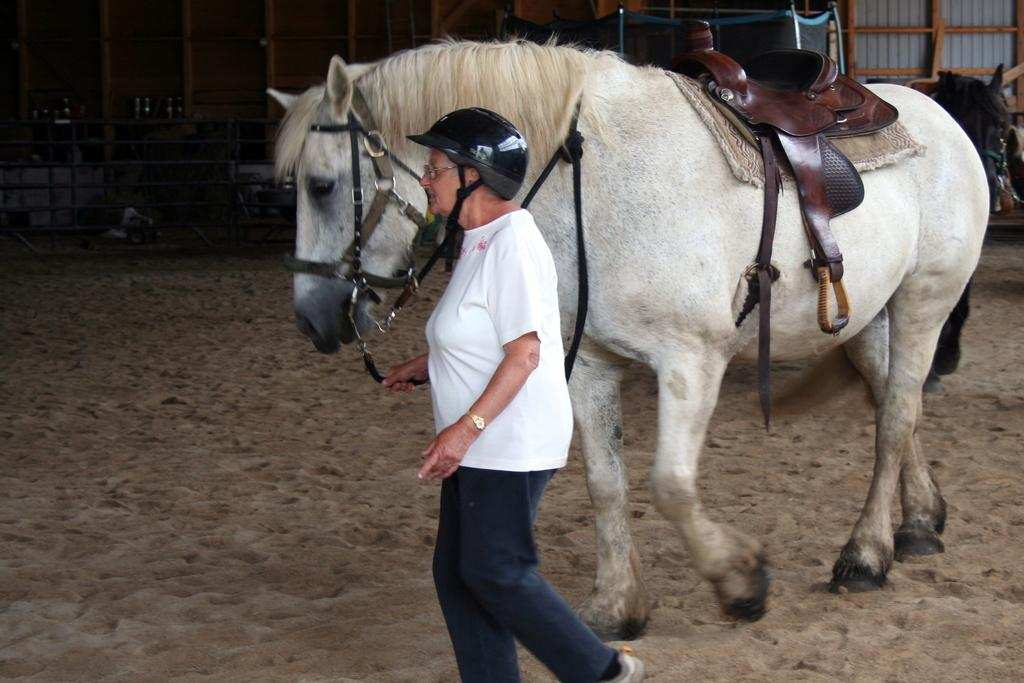What type of animal is in the image? There is a white horse in the image. What is the woman doing in the image? There is a woman walking in the image. What is the connection between the horse and the woman in the image? There is no direct connection between the horse and the woman in the image; they are separate subjects. What type of friction is present between the horse's hooves and the ground in the image? There is no information provided about the friction between the horse's hooves and the ground in the image. 